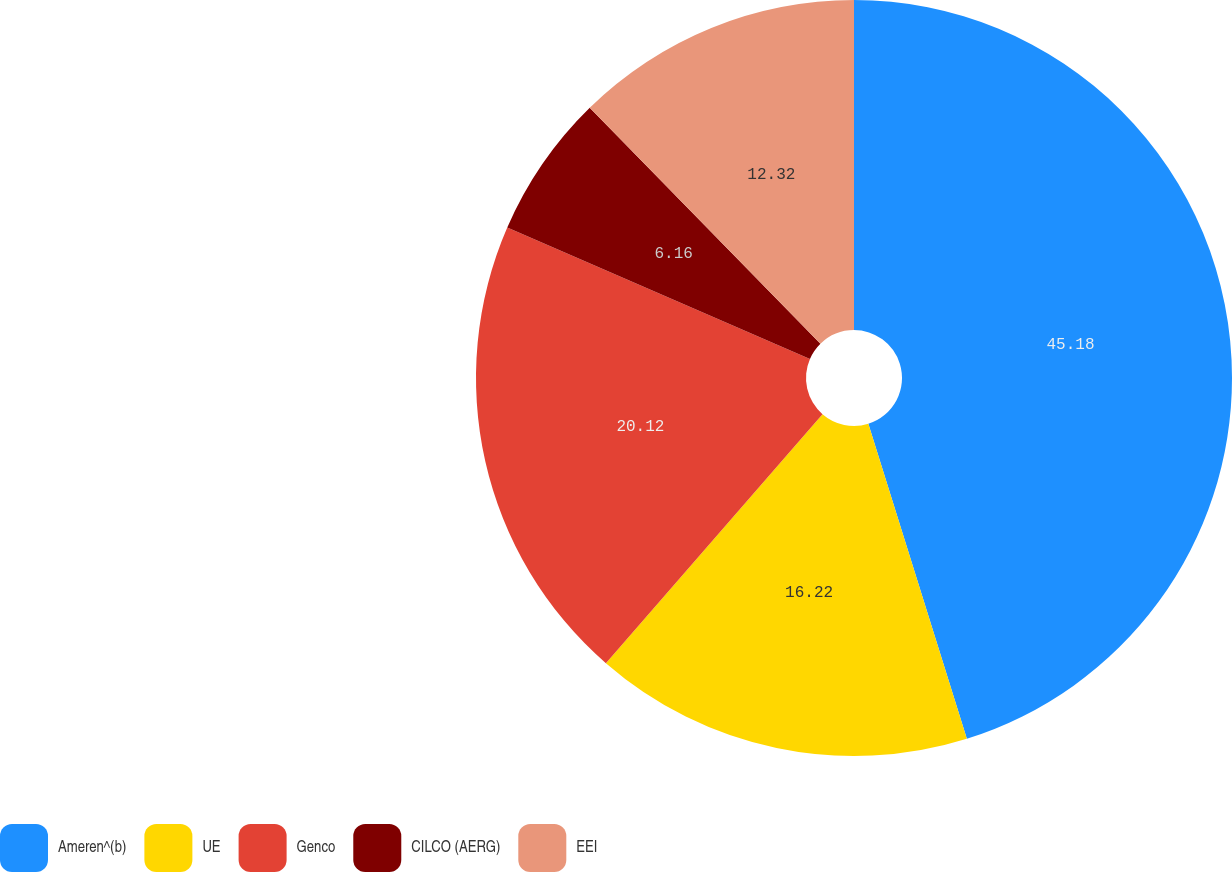Convert chart to OTSL. <chart><loc_0><loc_0><loc_500><loc_500><pie_chart><fcel>Ameren^(b)<fcel>UE<fcel>Genco<fcel>CILCO (AERG)<fcel>EEI<nl><fcel>45.17%<fcel>16.22%<fcel>20.12%<fcel>6.16%<fcel>12.32%<nl></chart> 